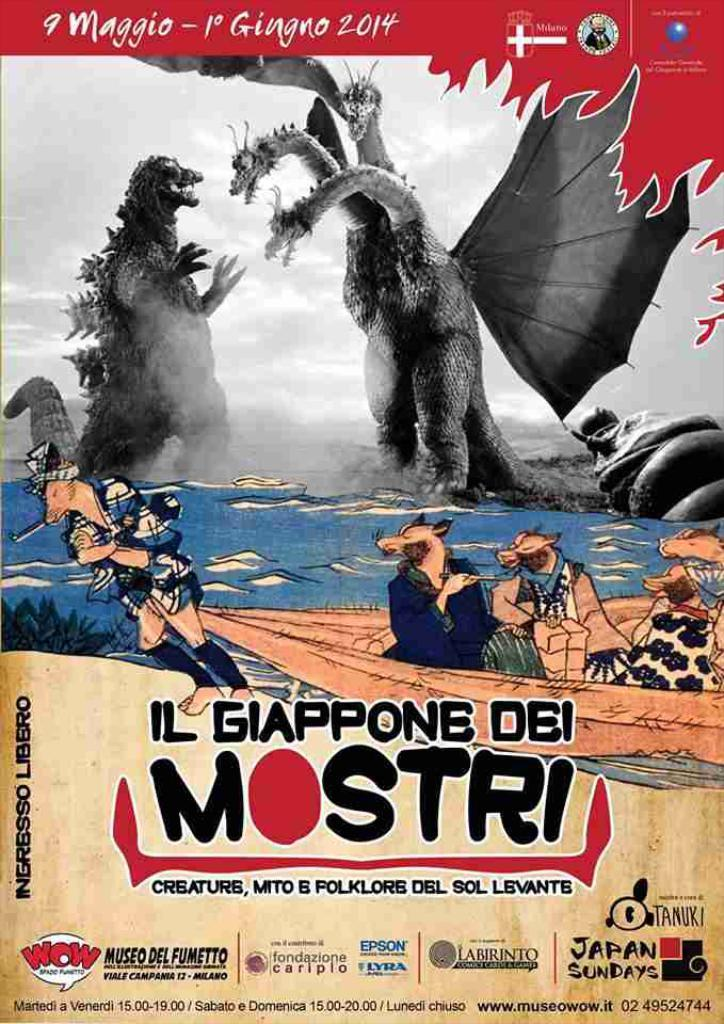<image>
Share a concise interpretation of the image provided. A poster about a monster movie called IL Giappone Dei Mostri 